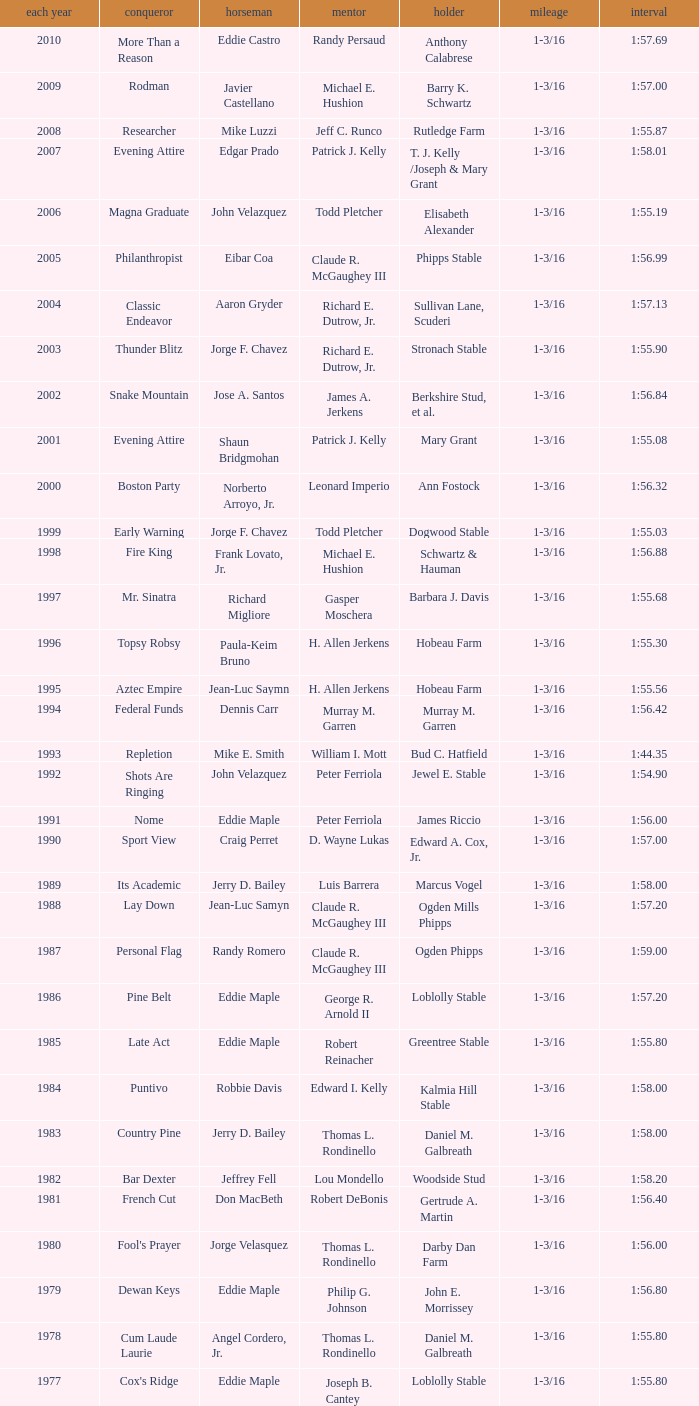What was the time for the winning horse Salford ii? 1:44.20. 